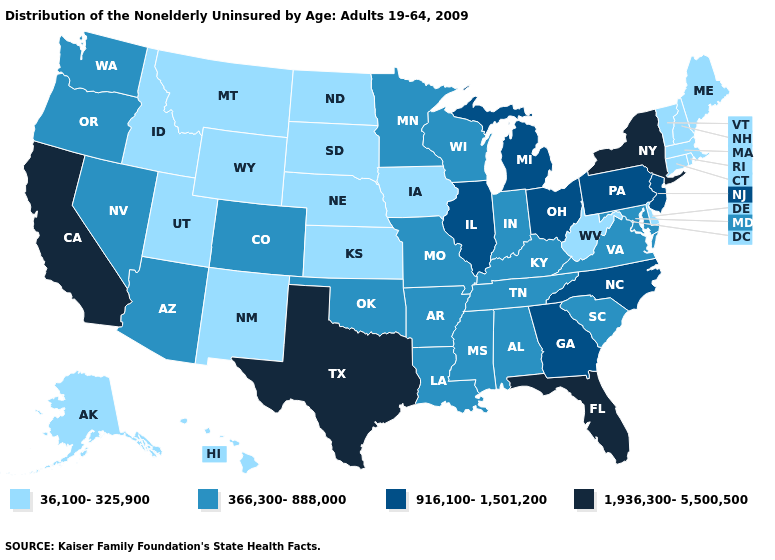Which states have the lowest value in the USA?
Keep it brief. Alaska, Connecticut, Delaware, Hawaii, Idaho, Iowa, Kansas, Maine, Massachusetts, Montana, Nebraska, New Hampshire, New Mexico, North Dakota, Rhode Island, South Dakota, Utah, Vermont, West Virginia, Wyoming. Does Kansas have the highest value in the USA?
Be succinct. No. Which states have the highest value in the USA?
Concise answer only. California, Florida, New York, Texas. Among the states that border Minnesota , does Wisconsin have the highest value?
Concise answer only. Yes. What is the value of Colorado?
Give a very brief answer. 366,300-888,000. Name the states that have a value in the range 36,100-325,900?
Give a very brief answer. Alaska, Connecticut, Delaware, Hawaii, Idaho, Iowa, Kansas, Maine, Massachusetts, Montana, Nebraska, New Hampshire, New Mexico, North Dakota, Rhode Island, South Dakota, Utah, Vermont, West Virginia, Wyoming. Does the first symbol in the legend represent the smallest category?
Keep it brief. Yes. How many symbols are there in the legend?
Give a very brief answer. 4. Among the states that border West Virginia , which have the highest value?
Concise answer only. Ohio, Pennsylvania. What is the lowest value in the USA?
Give a very brief answer. 36,100-325,900. Does the first symbol in the legend represent the smallest category?
Quick response, please. Yes. Which states have the lowest value in the USA?
Keep it brief. Alaska, Connecticut, Delaware, Hawaii, Idaho, Iowa, Kansas, Maine, Massachusetts, Montana, Nebraska, New Hampshire, New Mexico, North Dakota, Rhode Island, South Dakota, Utah, Vermont, West Virginia, Wyoming. Does Arizona have the same value as Minnesota?
Give a very brief answer. Yes. Name the states that have a value in the range 36,100-325,900?
Keep it brief. Alaska, Connecticut, Delaware, Hawaii, Idaho, Iowa, Kansas, Maine, Massachusetts, Montana, Nebraska, New Hampshire, New Mexico, North Dakota, Rhode Island, South Dakota, Utah, Vermont, West Virginia, Wyoming. What is the value of Utah?
Concise answer only. 36,100-325,900. 